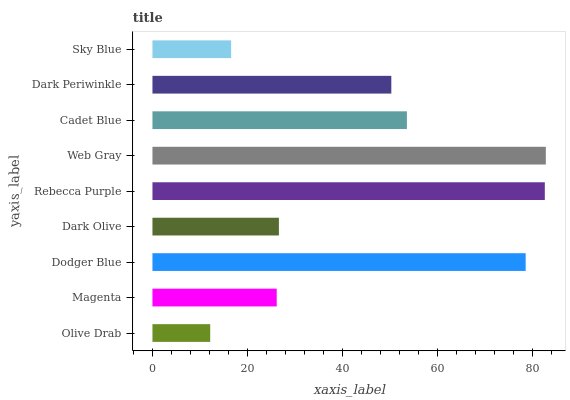Is Olive Drab the minimum?
Answer yes or no. Yes. Is Web Gray the maximum?
Answer yes or no. Yes. Is Magenta the minimum?
Answer yes or no. No. Is Magenta the maximum?
Answer yes or no. No. Is Magenta greater than Olive Drab?
Answer yes or no. Yes. Is Olive Drab less than Magenta?
Answer yes or no. Yes. Is Olive Drab greater than Magenta?
Answer yes or no. No. Is Magenta less than Olive Drab?
Answer yes or no. No. Is Dark Periwinkle the high median?
Answer yes or no. Yes. Is Dark Periwinkle the low median?
Answer yes or no. Yes. Is Web Gray the high median?
Answer yes or no. No. Is Magenta the low median?
Answer yes or no. No. 